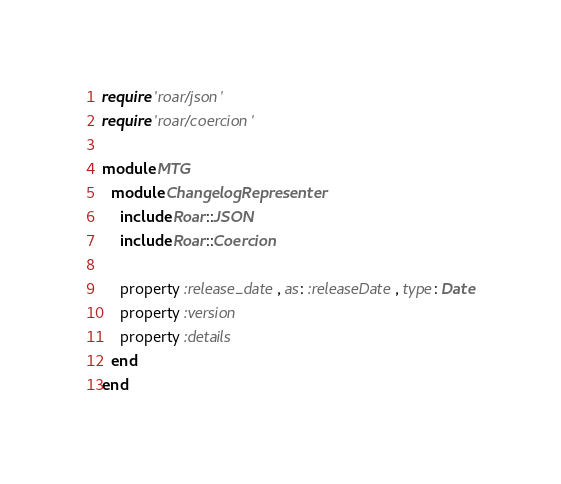<code> <loc_0><loc_0><loc_500><loc_500><_Ruby_>require 'roar/json'
require 'roar/coercion'

module MTG
  module ChangelogRepresenter
    include Roar::JSON
    include Roar::Coercion
  
    property :release_date, as: :releaseDate, type: Date
    property :version
    property :details
  end
end</code> 